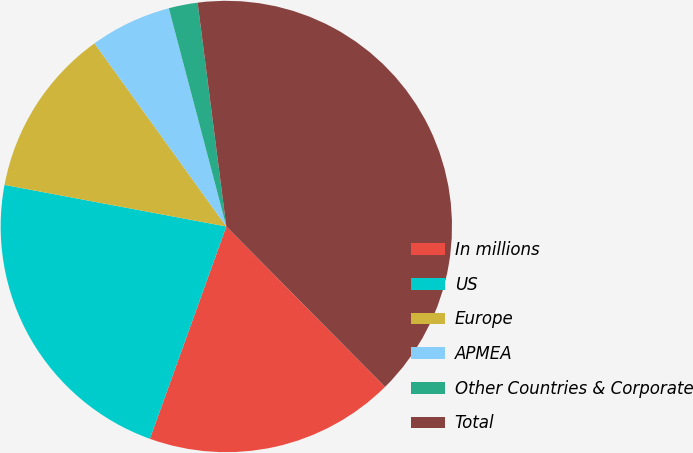Convert chart to OTSL. <chart><loc_0><loc_0><loc_500><loc_500><pie_chart><fcel>In millions<fcel>US<fcel>Europe<fcel>APMEA<fcel>Other Countries & Corporate<fcel>Total<nl><fcel>17.92%<fcel>22.45%<fcel>12.12%<fcel>5.83%<fcel>2.07%<fcel>39.61%<nl></chart> 